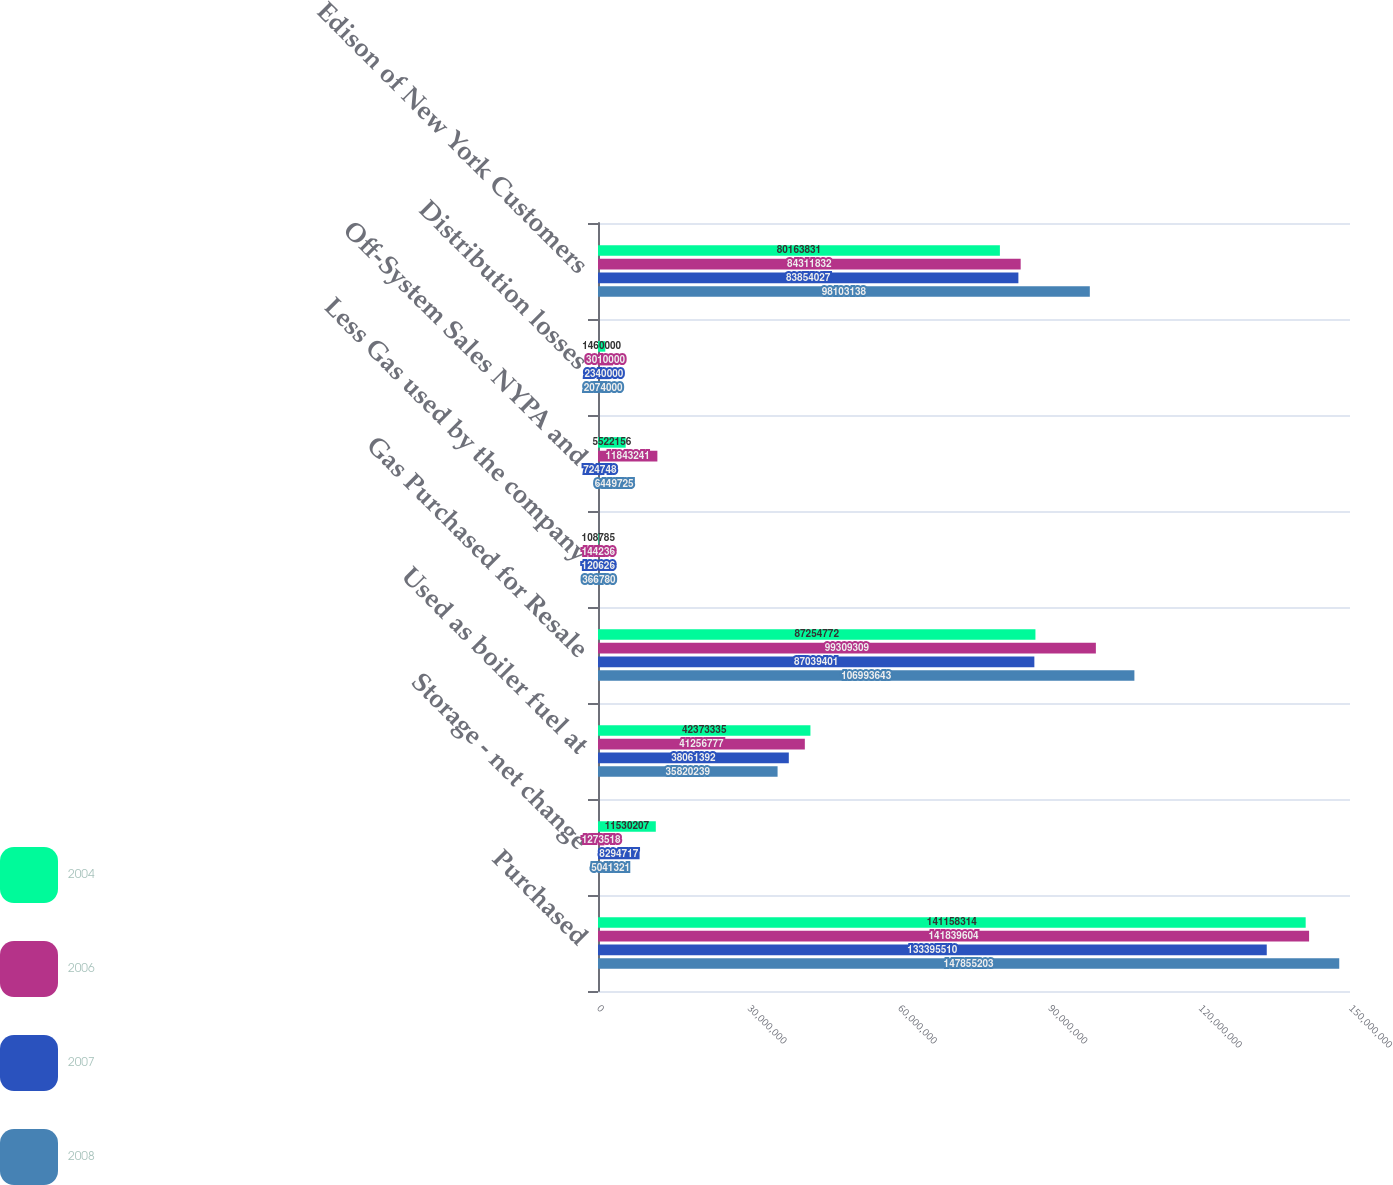<chart> <loc_0><loc_0><loc_500><loc_500><stacked_bar_chart><ecel><fcel>Purchased<fcel>Storage - net change<fcel>Used as boiler fuel at<fcel>Gas Purchased for Resale<fcel>Less Gas used by the company<fcel>Off-System Sales NYPA and<fcel>Distribution losses<fcel>Edison of New York Customers<nl><fcel>2004<fcel>1.41158e+08<fcel>1.15302e+07<fcel>4.23733e+07<fcel>8.72548e+07<fcel>108785<fcel>5.52216e+06<fcel>1.46e+06<fcel>8.01638e+07<nl><fcel>2006<fcel>1.4184e+08<fcel>1.27352e+06<fcel>4.12568e+07<fcel>9.93093e+07<fcel>144236<fcel>1.18432e+07<fcel>3.01e+06<fcel>8.43118e+07<nl><fcel>2007<fcel>1.33396e+08<fcel>8.29472e+06<fcel>3.80614e+07<fcel>8.70394e+07<fcel>120626<fcel>724748<fcel>2.34e+06<fcel>8.3854e+07<nl><fcel>2008<fcel>1.47855e+08<fcel>5.04132e+06<fcel>3.58202e+07<fcel>1.06994e+08<fcel>366780<fcel>6.44972e+06<fcel>2.074e+06<fcel>9.81031e+07<nl></chart> 